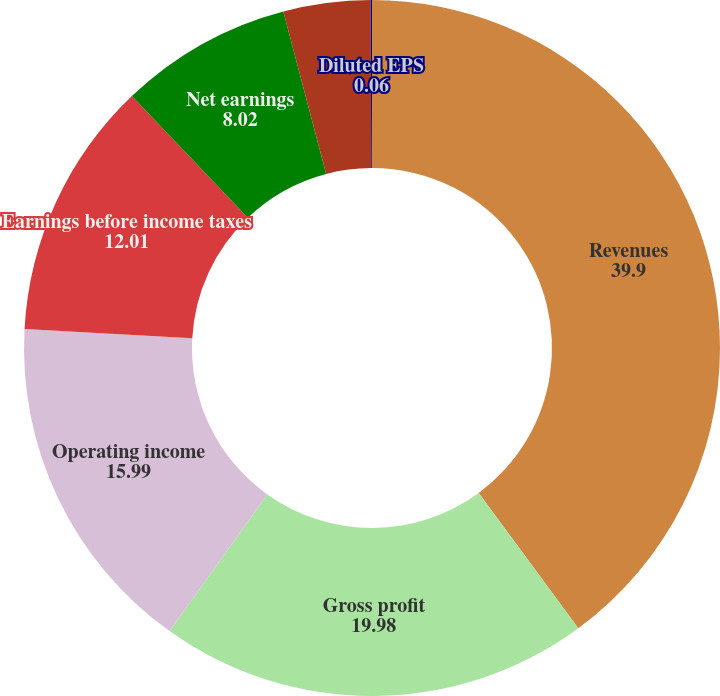<chart> <loc_0><loc_0><loc_500><loc_500><pie_chart><fcel>Revenues<fcel>Gross profit<fcel>Operating income<fcel>Earnings before income taxes<fcel>Net earnings<fcel>Basic EPS<fcel>Diluted EPS<nl><fcel>39.9%<fcel>19.98%<fcel>15.99%<fcel>12.01%<fcel>8.02%<fcel>4.04%<fcel>0.06%<nl></chart> 